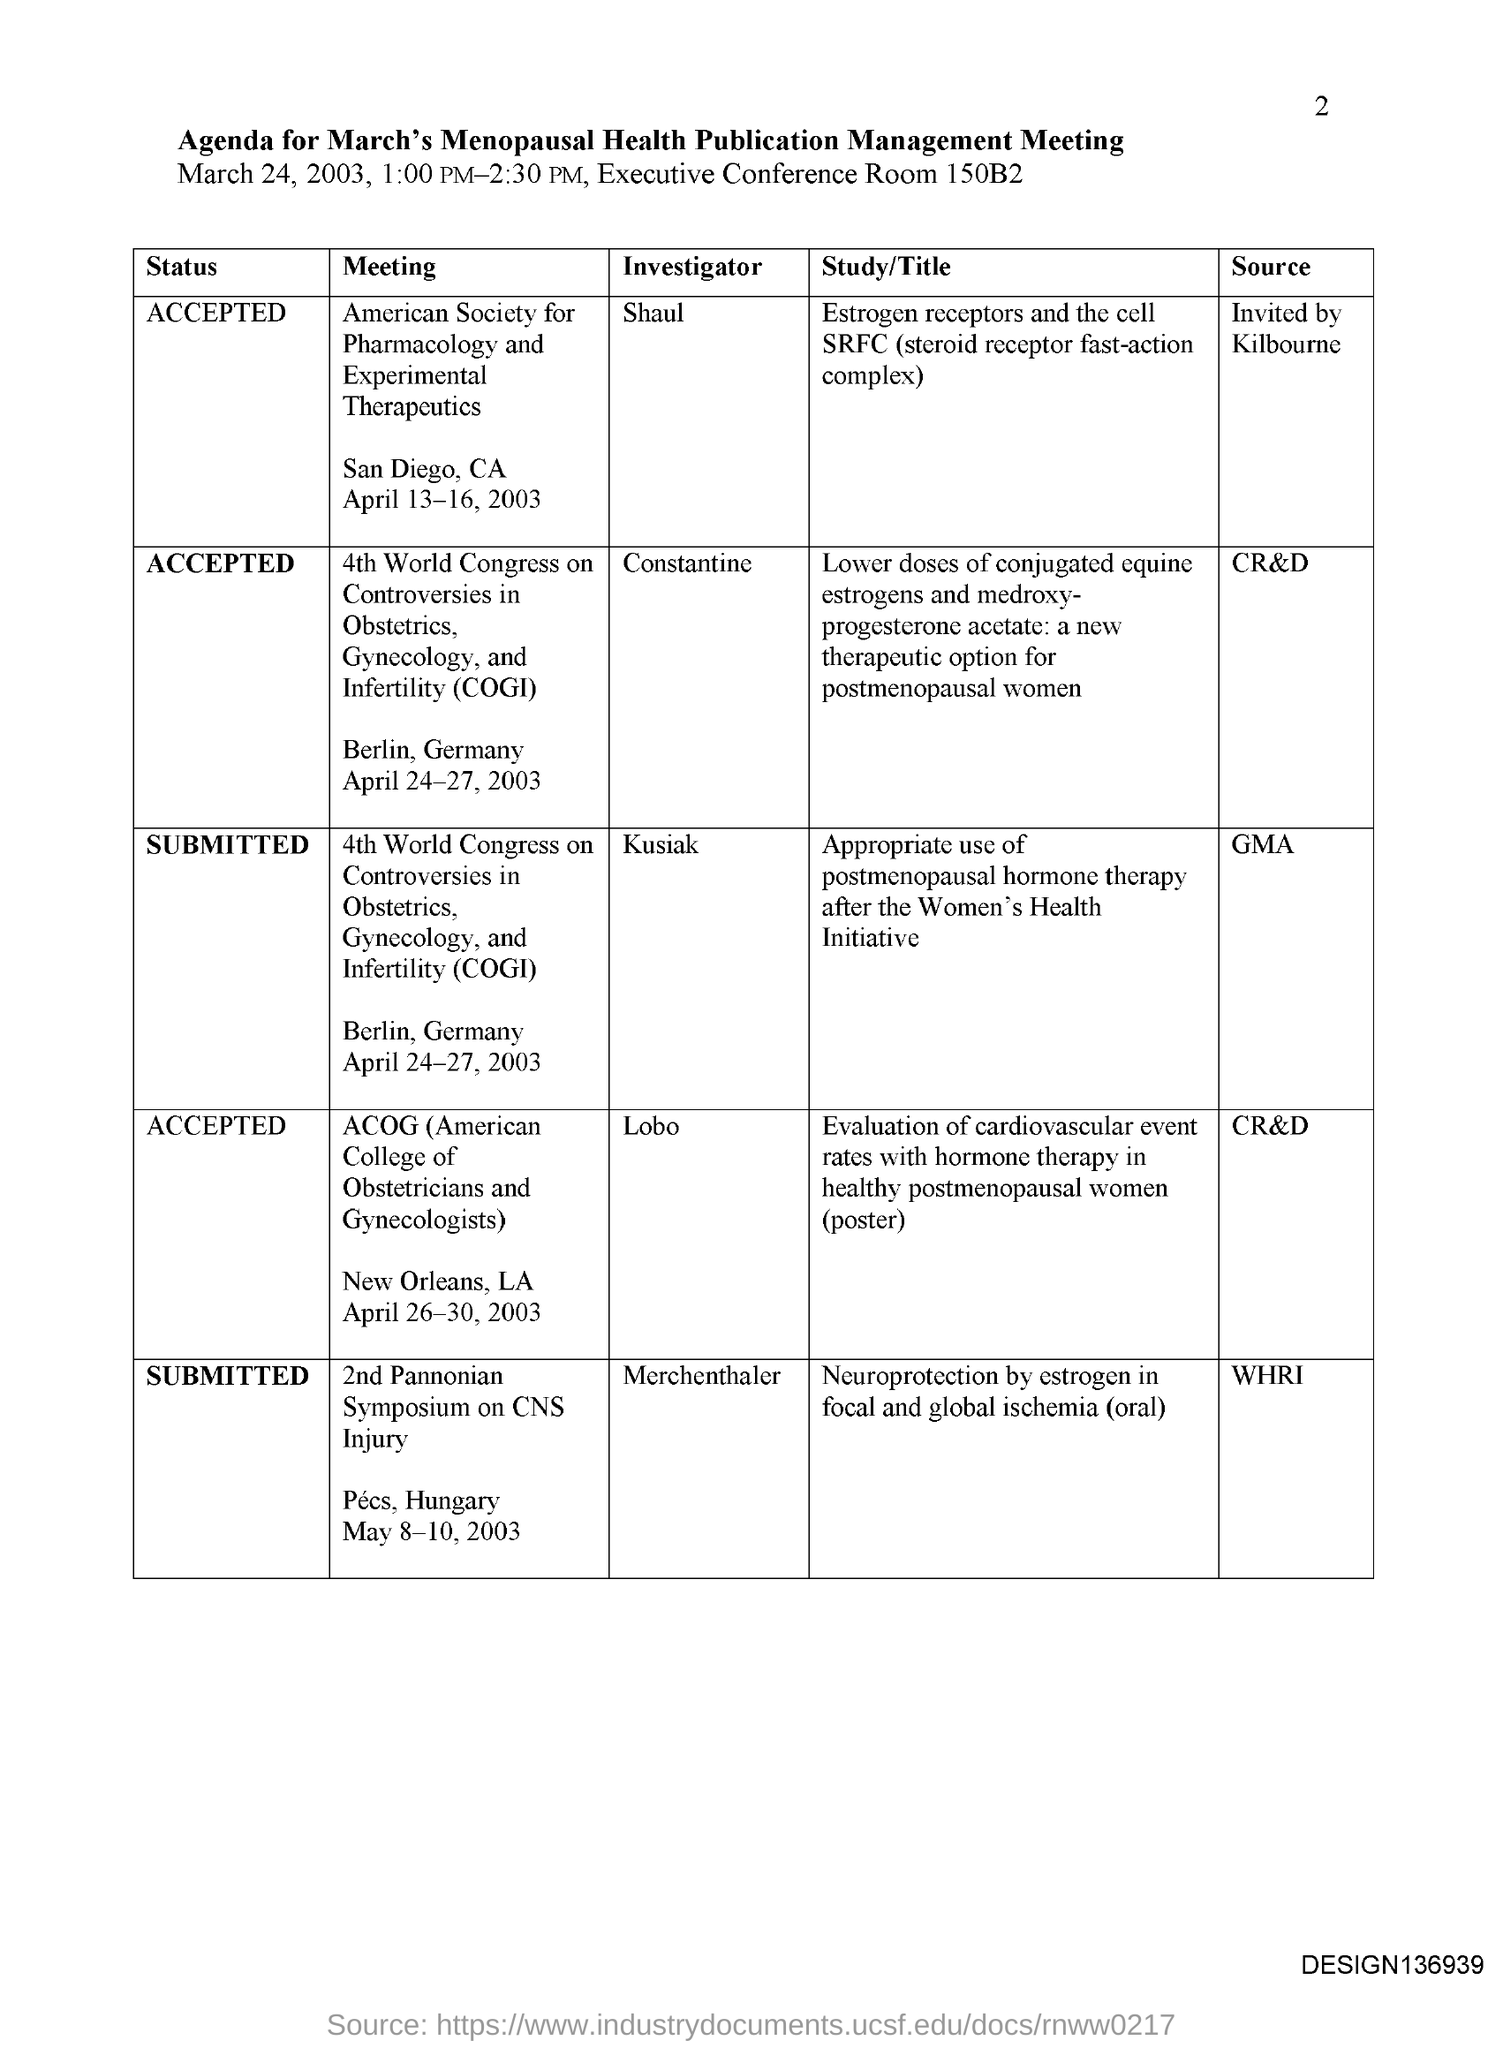Indicate a few pertinent items in this graphic. The investigator/author for the ACOG meeting is Lobo. The American Society for Pharmacology and Experimental Therapeutics (ASPET) will be holding its meeting in San Diego, California. The investigator/author for the American society for pharmacology and experimental therapeutics meeting is Shaul. The American College of Obstetricians and Gynecologists (ACOG) meeting will be held on April 26-30, 2003. The American Society for Pharmacology and Experimental Therapeutics meeting is to be held on April 13-16, 2003. 